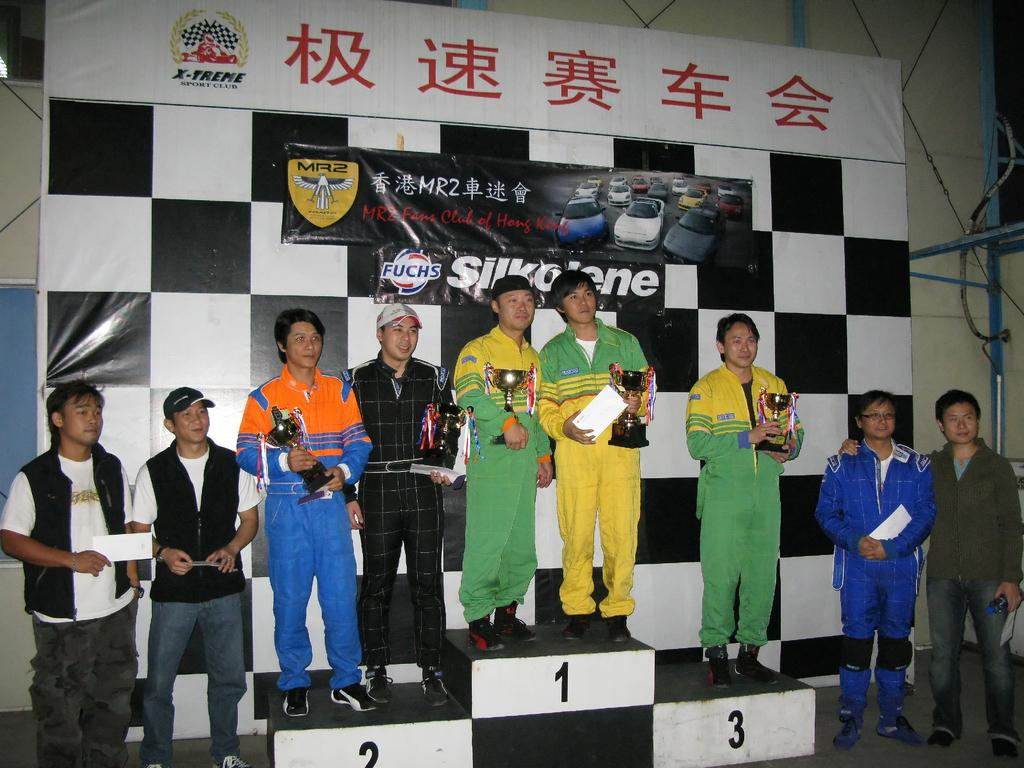What is the main focus of the image? The main focus of the image is the people in the center. What is located behind the people? There is a banner with text behind the people. What are the people holding in the image? Five people are holding shields. What type of quartz can be seen in the hands of the people in the image? There is no quartz present in the image; the people are holding shields. How does the cough affect the people in the image? There is no mention of a cough in the image; it only shows people holding shields and a banner with text. 